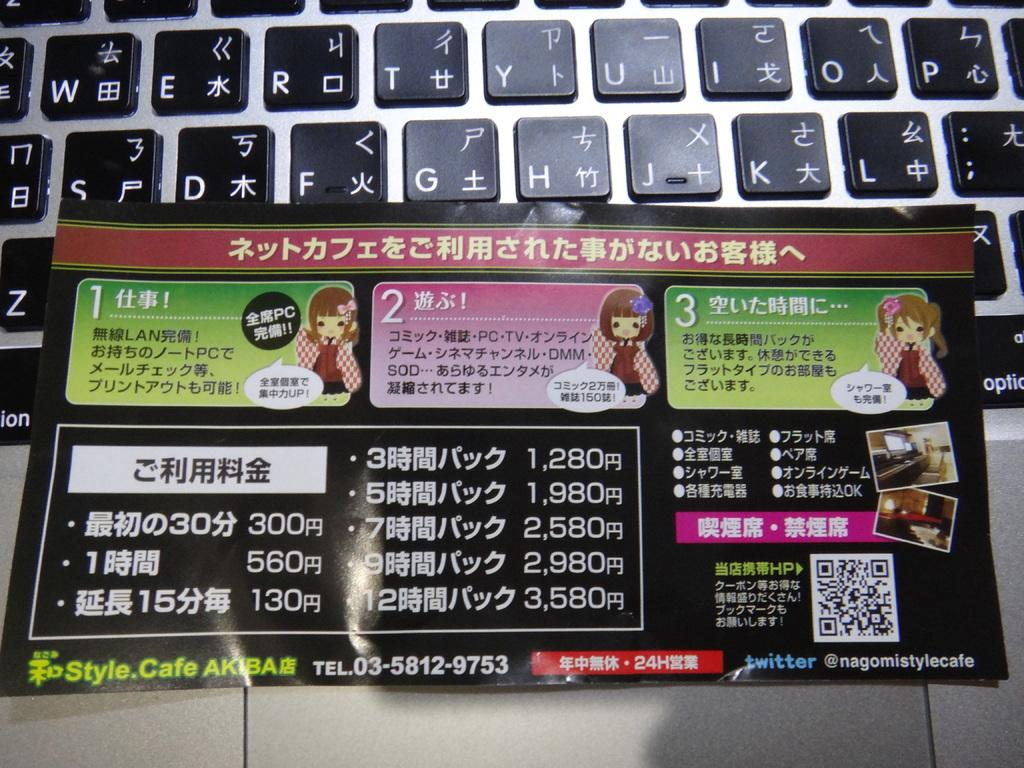<image>
Describe the image concisely. a card is laying on a keyboard, all written in chinese 